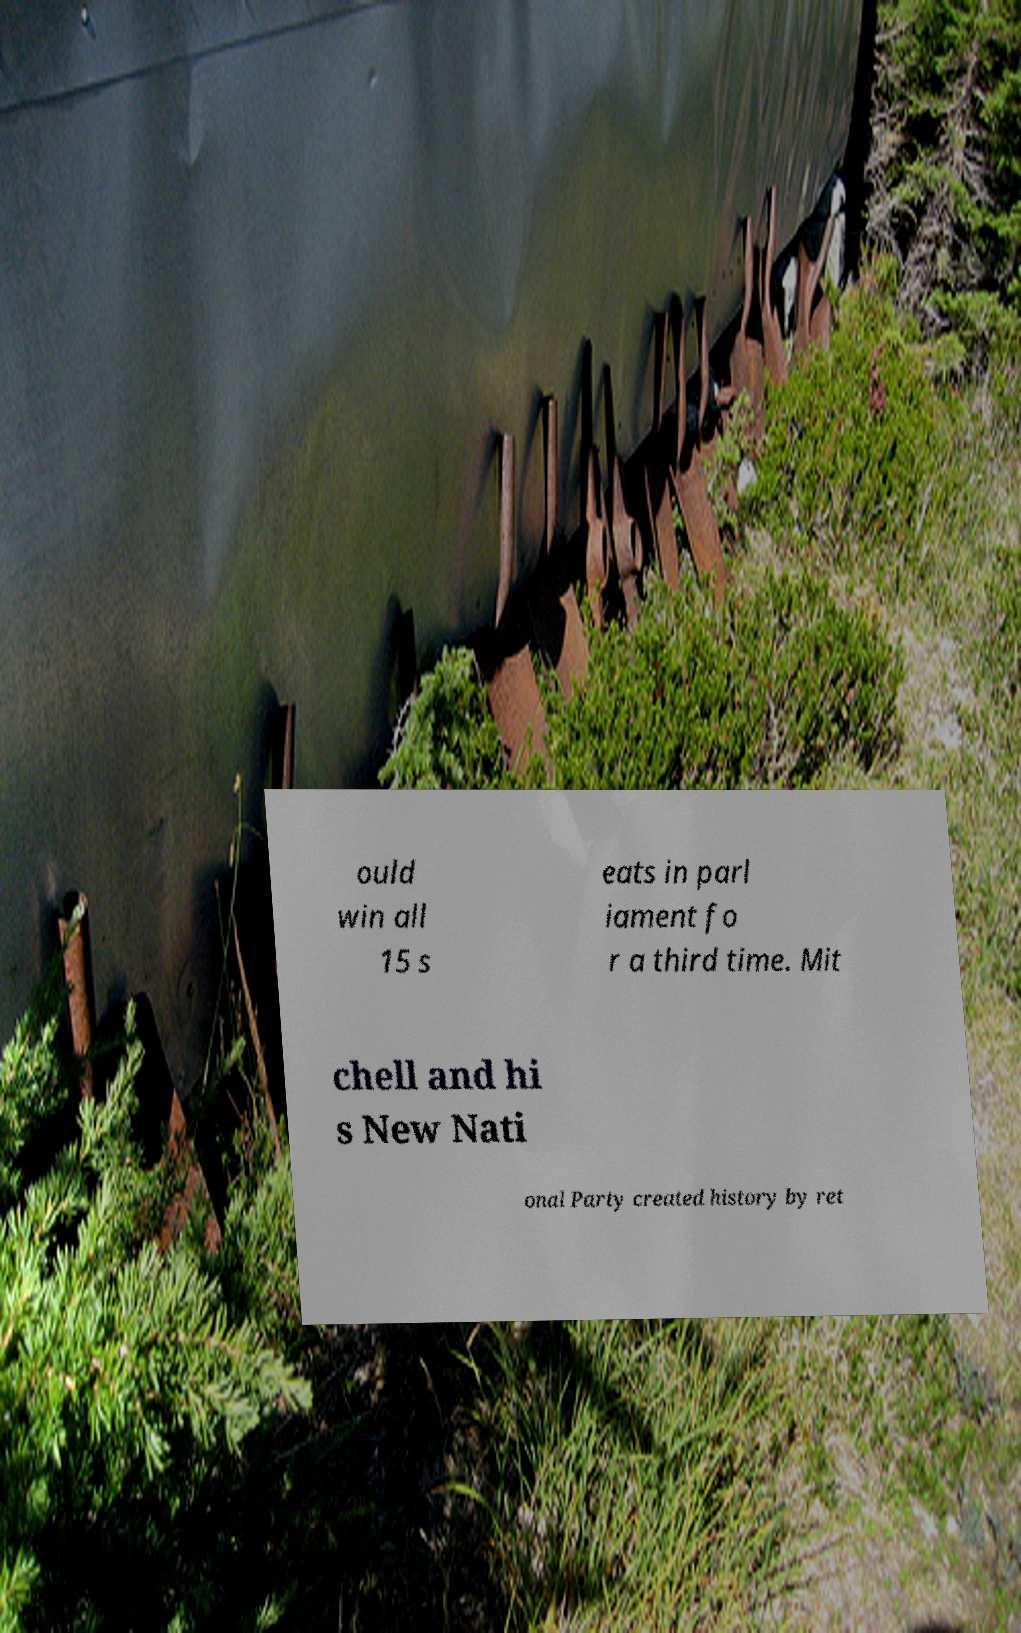Please read and relay the text visible in this image. What does it say? ould win all 15 s eats in parl iament fo r a third time. Mit chell and hi s New Nati onal Party created history by ret 